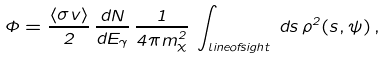Convert formula to latex. <formula><loc_0><loc_0><loc_500><loc_500>\Phi = \frac { \langle \sigma v \rangle } { 2 } \, \frac { d N } { d E _ { \gamma } } \, \frac { 1 } { 4 \pi m _ { \chi } ^ { 2 } } \, \int _ { l i n e o f s i g h t } \, d s \, \rho ^ { 2 } ( s , \psi ) \, ,</formula> 